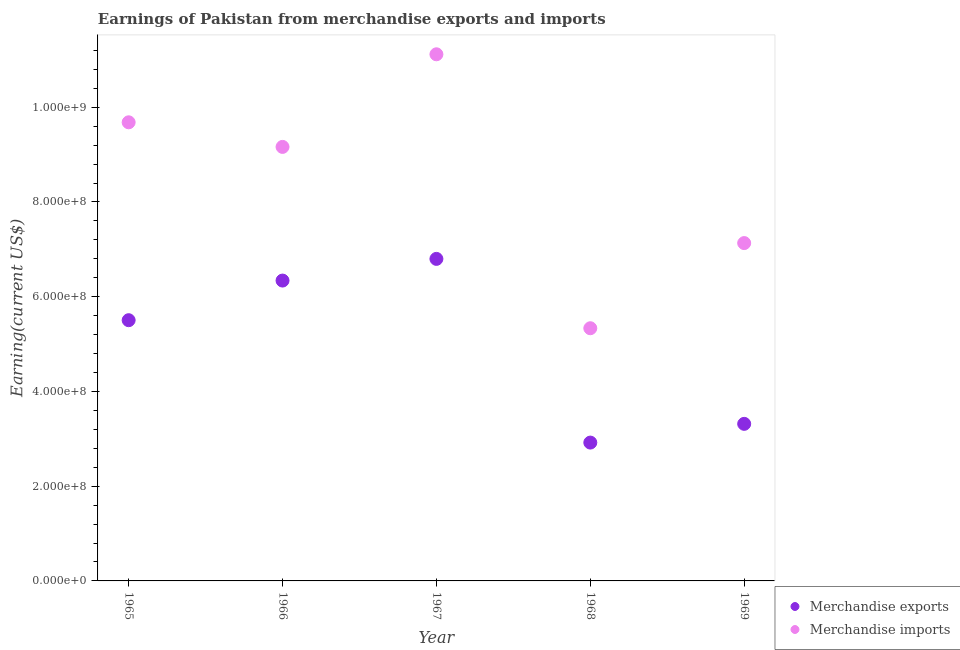How many different coloured dotlines are there?
Provide a succinct answer. 2. Is the number of dotlines equal to the number of legend labels?
Your response must be concise. Yes. What is the earnings from merchandise exports in 1966?
Keep it short and to the point. 6.34e+08. Across all years, what is the maximum earnings from merchandise exports?
Make the answer very short. 6.80e+08. Across all years, what is the minimum earnings from merchandise exports?
Offer a terse response. 2.92e+08. In which year was the earnings from merchandise imports maximum?
Keep it short and to the point. 1967. In which year was the earnings from merchandise exports minimum?
Offer a terse response. 1968. What is the total earnings from merchandise exports in the graph?
Offer a very short reply. 2.49e+09. What is the difference between the earnings from merchandise exports in 1966 and that in 1968?
Make the answer very short. 3.42e+08. What is the difference between the earnings from merchandise imports in 1965 and the earnings from merchandise exports in 1967?
Offer a very short reply. 2.88e+08. What is the average earnings from merchandise imports per year?
Offer a very short reply. 8.49e+08. In the year 1967, what is the difference between the earnings from merchandise exports and earnings from merchandise imports?
Your answer should be very brief. -4.32e+08. In how many years, is the earnings from merchandise exports greater than 160000000 US$?
Keep it short and to the point. 5. What is the ratio of the earnings from merchandise imports in 1967 to that in 1969?
Offer a very short reply. 1.56. Is the difference between the earnings from merchandise imports in 1966 and 1968 greater than the difference between the earnings from merchandise exports in 1966 and 1968?
Provide a short and direct response. Yes. What is the difference between the highest and the second highest earnings from merchandise exports?
Your answer should be compact. 4.58e+07. What is the difference between the highest and the lowest earnings from merchandise imports?
Keep it short and to the point. 5.78e+08. Is the sum of the earnings from merchandise exports in 1966 and 1967 greater than the maximum earnings from merchandise imports across all years?
Give a very brief answer. Yes. Does the earnings from merchandise imports monotonically increase over the years?
Give a very brief answer. No. Is the earnings from merchandise exports strictly greater than the earnings from merchandise imports over the years?
Keep it short and to the point. No. How many dotlines are there?
Provide a succinct answer. 2. How many years are there in the graph?
Give a very brief answer. 5. How many legend labels are there?
Give a very brief answer. 2. How are the legend labels stacked?
Provide a succinct answer. Vertical. What is the title of the graph?
Your response must be concise. Earnings of Pakistan from merchandise exports and imports. Does "US$" appear as one of the legend labels in the graph?
Your response must be concise. No. What is the label or title of the Y-axis?
Make the answer very short. Earning(current US$). What is the Earning(current US$) of Merchandise exports in 1965?
Make the answer very short. 5.50e+08. What is the Earning(current US$) of Merchandise imports in 1965?
Give a very brief answer. 9.68e+08. What is the Earning(current US$) in Merchandise exports in 1966?
Offer a terse response. 6.34e+08. What is the Earning(current US$) in Merchandise imports in 1966?
Your response must be concise. 9.16e+08. What is the Earning(current US$) in Merchandise exports in 1967?
Make the answer very short. 6.80e+08. What is the Earning(current US$) of Merchandise imports in 1967?
Provide a short and direct response. 1.11e+09. What is the Earning(current US$) of Merchandise exports in 1968?
Give a very brief answer. 2.92e+08. What is the Earning(current US$) in Merchandise imports in 1968?
Offer a very short reply. 5.33e+08. What is the Earning(current US$) in Merchandise exports in 1969?
Your answer should be compact. 3.32e+08. What is the Earning(current US$) of Merchandise imports in 1969?
Offer a terse response. 7.13e+08. Across all years, what is the maximum Earning(current US$) of Merchandise exports?
Ensure brevity in your answer.  6.80e+08. Across all years, what is the maximum Earning(current US$) of Merchandise imports?
Provide a succinct answer. 1.11e+09. Across all years, what is the minimum Earning(current US$) in Merchandise exports?
Ensure brevity in your answer.  2.92e+08. Across all years, what is the minimum Earning(current US$) in Merchandise imports?
Provide a short and direct response. 5.33e+08. What is the total Earning(current US$) of Merchandise exports in the graph?
Provide a short and direct response. 2.49e+09. What is the total Earning(current US$) in Merchandise imports in the graph?
Ensure brevity in your answer.  4.24e+09. What is the difference between the Earning(current US$) of Merchandise exports in 1965 and that in 1966?
Your response must be concise. -8.37e+07. What is the difference between the Earning(current US$) of Merchandise imports in 1965 and that in 1966?
Make the answer very short. 5.19e+07. What is the difference between the Earning(current US$) in Merchandise exports in 1965 and that in 1967?
Keep it short and to the point. -1.29e+08. What is the difference between the Earning(current US$) in Merchandise imports in 1965 and that in 1967?
Provide a succinct answer. -1.44e+08. What is the difference between the Earning(current US$) in Merchandise exports in 1965 and that in 1968?
Offer a very short reply. 2.58e+08. What is the difference between the Earning(current US$) in Merchandise imports in 1965 and that in 1968?
Your response must be concise. 4.35e+08. What is the difference between the Earning(current US$) in Merchandise exports in 1965 and that in 1969?
Ensure brevity in your answer.  2.19e+08. What is the difference between the Earning(current US$) in Merchandise imports in 1965 and that in 1969?
Provide a succinct answer. 2.55e+08. What is the difference between the Earning(current US$) in Merchandise exports in 1966 and that in 1967?
Offer a very short reply. -4.58e+07. What is the difference between the Earning(current US$) of Merchandise imports in 1966 and that in 1967?
Make the answer very short. -1.96e+08. What is the difference between the Earning(current US$) in Merchandise exports in 1966 and that in 1968?
Provide a short and direct response. 3.42e+08. What is the difference between the Earning(current US$) in Merchandise imports in 1966 and that in 1968?
Your answer should be very brief. 3.83e+08. What is the difference between the Earning(current US$) of Merchandise exports in 1966 and that in 1969?
Provide a succinct answer. 3.03e+08. What is the difference between the Earning(current US$) of Merchandise imports in 1966 and that in 1969?
Your response must be concise. 2.03e+08. What is the difference between the Earning(current US$) of Merchandise exports in 1967 and that in 1968?
Your answer should be very brief. 3.88e+08. What is the difference between the Earning(current US$) of Merchandise imports in 1967 and that in 1968?
Give a very brief answer. 5.78e+08. What is the difference between the Earning(current US$) in Merchandise exports in 1967 and that in 1969?
Your answer should be compact. 3.48e+08. What is the difference between the Earning(current US$) of Merchandise imports in 1967 and that in 1969?
Ensure brevity in your answer.  3.99e+08. What is the difference between the Earning(current US$) of Merchandise exports in 1968 and that in 1969?
Your response must be concise. -3.96e+07. What is the difference between the Earning(current US$) in Merchandise imports in 1968 and that in 1969?
Your answer should be compact. -1.80e+08. What is the difference between the Earning(current US$) of Merchandise exports in 1965 and the Earning(current US$) of Merchandise imports in 1966?
Keep it short and to the point. -3.66e+08. What is the difference between the Earning(current US$) in Merchandise exports in 1965 and the Earning(current US$) in Merchandise imports in 1967?
Make the answer very short. -5.61e+08. What is the difference between the Earning(current US$) in Merchandise exports in 1965 and the Earning(current US$) in Merchandise imports in 1968?
Give a very brief answer. 1.70e+07. What is the difference between the Earning(current US$) of Merchandise exports in 1965 and the Earning(current US$) of Merchandise imports in 1969?
Offer a very short reply. -1.63e+08. What is the difference between the Earning(current US$) of Merchandise exports in 1966 and the Earning(current US$) of Merchandise imports in 1967?
Keep it short and to the point. -4.78e+08. What is the difference between the Earning(current US$) of Merchandise exports in 1966 and the Earning(current US$) of Merchandise imports in 1968?
Your answer should be compact. 1.01e+08. What is the difference between the Earning(current US$) in Merchandise exports in 1966 and the Earning(current US$) in Merchandise imports in 1969?
Make the answer very short. -7.91e+07. What is the difference between the Earning(current US$) of Merchandise exports in 1967 and the Earning(current US$) of Merchandise imports in 1968?
Ensure brevity in your answer.  1.46e+08. What is the difference between the Earning(current US$) of Merchandise exports in 1967 and the Earning(current US$) of Merchandise imports in 1969?
Your answer should be compact. -3.34e+07. What is the difference between the Earning(current US$) of Merchandise exports in 1968 and the Earning(current US$) of Merchandise imports in 1969?
Ensure brevity in your answer.  -4.21e+08. What is the average Earning(current US$) of Merchandise exports per year?
Your answer should be very brief. 4.98e+08. What is the average Earning(current US$) of Merchandise imports per year?
Your response must be concise. 8.49e+08. In the year 1965, what is the difference between the Earning(current US$) in Merchandise exports and Earning(current US$) in Merchandise imports?
Offer a terse response. -4.18e+08. In the year 1966, what is the difference between the Earning(current US$) in Merchandise exports and Earning(current US$) in Merchandise imports?
Offer a terse response. -2.82e+08. In the year 1967, what is the difference between the Earning(current US$) of Merchandise exports and Earning(current US$) of Merchandise imports?
Make the answer very short. -4.32e+08. In the year 1968, what is the difference between the Earning(current US$) in Merchandise exports and Earning(current US$) in Merchandise imports?
Keep it short and to the point. -2.41e+08. In the year 1969, what is the difference between the Earning(current US$) in Merchandise exports and Earning(current US$) in Merchandise imports?
Your response must be concise. -3.82e+08. What is the ratio of the Earning(current US$) in Merchandise exports in 1965 to that in 1966?
Provide a succinct answer. 0.87. What is the ratio of the Earning(current US$) in Merchandise imports in 1965 to that in 1966?
Offer a very short reply. 1.06. What is the ratio of the Earning(current US$) in Merchandise exports in 1965 to that in 1967?
Your answer should be compact. 0.81. What is the ratio of the Earning(current US$) in Merchandise imports in 1965 to that in 1967?
Make the answer very short. 0.87. What is the ratio of the Earning(current US$) of Merchandise exports in 1965 to that in 1968?
Offer a very short reply. 1.88. What is the ratio of the Earning(current US$) of Merchandise imports in 1965 to that in 1968?
Keep it short and to the point. 1.81. What is the ratio of the Earning(current US$) of Merchandise exports in 1965 to that in 1969?
Your response must be concise. 1.66. What is the ratio of the Earning(current US$) of Merchandise imports in 1965 to that in 1969?
Your response must be concise. 1.36. What is the ratio of the Earning(current US$) of Merchandise exports in 1966 to that in 1967?
Keep it short and to the point. 0.93. What is the ratio of the Earning(current US$) in Merchandise imports in 1966 to that in 1967?
Offer a terse response. 0.82. What is the ratio of the Earning(current US$) of Merchandise exports in 1966 to that in 1968?
Offer a terse response. 2.17. What is the ratio of the Earning(current US$) in Merchandise imports in 1966 to that in 1968?
Your answer should be very brief. 1.72. What is the ratio of the Earning(current US$) in Merchandise exports in 1966 to that in 1969?
Ensure brevity in your answer.  1.91. What is the ratio of the Earning(current US$) of Merchandise imports in 1966 to that in 1969?
Your answer should be very brief. 1.28. What is the ratio of the Earning(current US$) of Merchandise exports in 1967 to that in 1968?
Your response must be concise. 2.33. What is the ratio of the Earning(current US$) in Merchandise imports in 1967 to that in 1968?
Your answer should be very brief. 2.08. What is the ratio of the Earning(current US$) in Merchandise exports in 1967 to that in 1969?
Your response must be concise. 2.05. What is the ratio of the Earning(current US$) of Merchandise imports in 1967 to that in 1969?
Ensure brevity in your answer.  1.56. What is the ratio of the Earning(current US$) of Merchandise exports in 1968 to that in 1969?
Your response must be concise. 0.88. What is the ratio of the Earning(current US$) of Merchandise imports in 1968 to that in 1969?
Offer a very short reply. 0.75. What is the difference between the highest and the second highest Earning(current US$) in Merchandise exports?
Your answer should be compact. 4.58e+07. What is the difference between the highest and the second highest Earning(current US$) in Merchandise imports?
Provide a succinct answer. 1.44e+08. What is the difference between the highest and the lowest Earning(current US$) of Merchandise exports?
Provide a short and direct response. 3.88e+08. What is the difference between the highest and the lowest Earning(current US$) in Merchandise imports?
Give a very brief answer. 5.78e+08. 